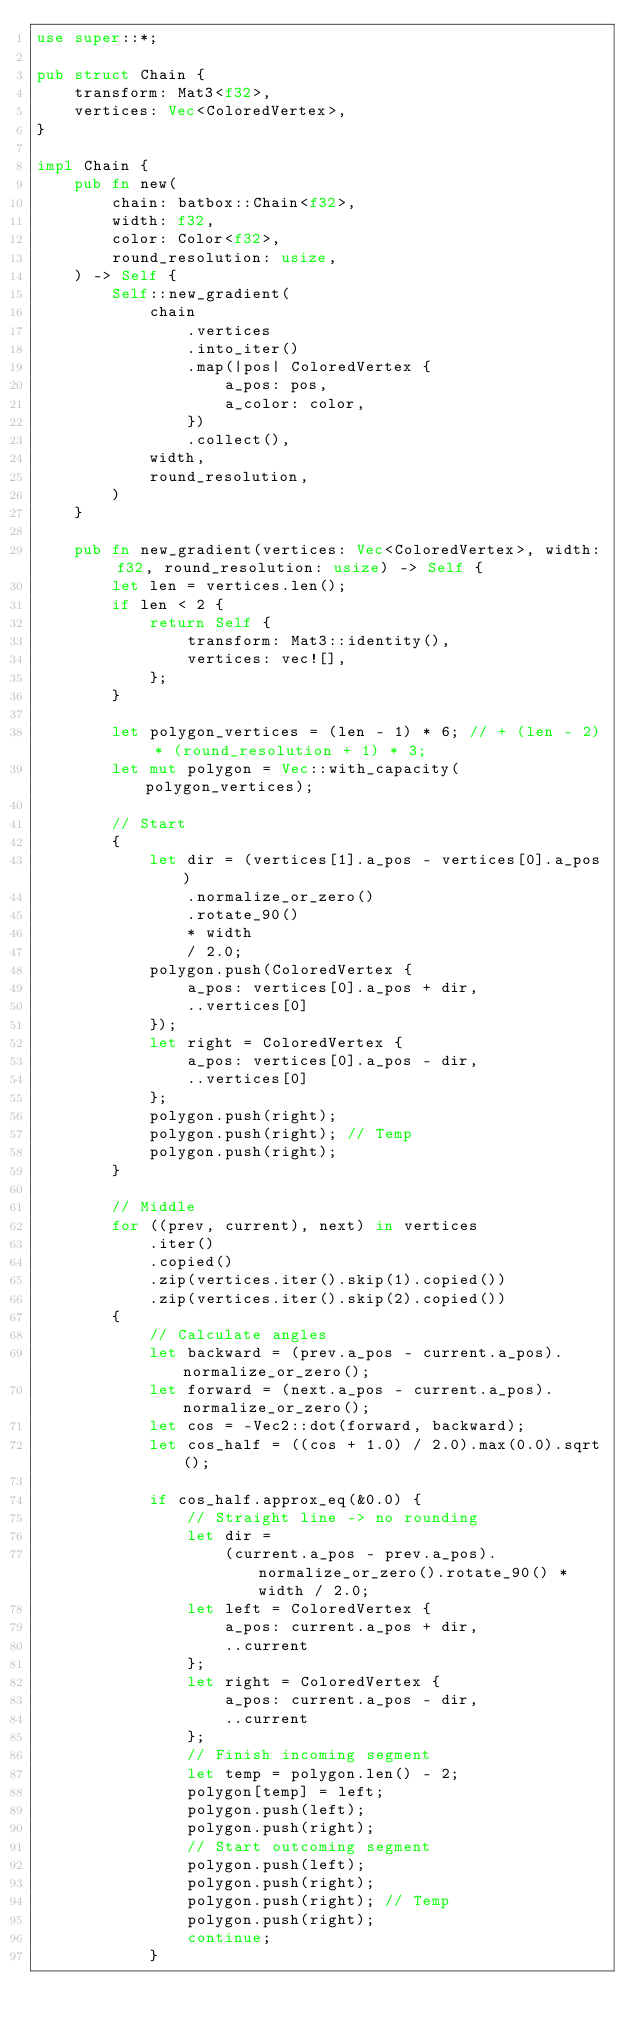<code> <loc_0><loc_0><loc_500><loc_500><_Rust_>use super::*;

pub struct Chain {
    transform: Mat3<f32>,
    vertices: Vec<ColoredVertex>,
}

impl Chain {
    pub fn new(
        chain: batbox::Chain<f32>,
        width: f32,
        color: Color<f32>,
        round_resolution: usize,
    ) -> Self {
        Self::new_gradient(
            chain
                .vertices
                .into_iter()
                .map(|pos| ColoredVertex {
                    a_pos: pos,
                    a_color: color,
                })
                .collect(),
            width,
            round_resolution,
        )
    }

    pub fn new_gradient(vertices: Vec<ColoredVertex>, width: f32, round_resolution: usize) -> Self {
        let len = vertices.len();
        if len < 2 {
            return Self {
                transform: Mat3::identity(),
                vertices: vec![],
            };
        }

        let polygon_vertices = (len - 1) * 6; // + (len - 2) * (round_resolution + 1) * 3;
        let mut polygon = Vec::with_capacity(polygon_vertices);

        // Start
        {
            let dir = (vertices[1].a_pos - vertices[0].a_pos)
                .normalize_or_zero()
                .rotate_90()
                * width
                / 2.0;
            polygon.push(ColoredVertex {
                a_pos: vertices[0].a_pos + dir,
                ..vertices[0]
            });
            let right = ColoredVertex {
                a_pos: vertices[0].a_pos - dir,
                ..vertices[0]
            };
            polygon.push(right);
            polygon.push(right); // Temp
            polygon.push(right);
        }

        // Middle
        for ((prev, current), next) in vertices
            .iter()
            .copied()
            .zip(vertices.iter().skip(1).copied())
            .zip(vertices.iter().skip(2).copied())
        {
            // Calculate angles
            let backward = (prev.a_pos - current.a_pos).normalize_or_zero();
            let forward = (next.a_pos - current.a_pos).normalize_or_zero();
            let cos = -Vec2::dot(forward, backward);
            let cos_half = ((cos + 1.0) / 2.0).max(0.0).sqrt();

            if cos_half.approx_eq(&0.0) {
                // Straight line -> no rounding
                let dir =
                    (current.a_pos - prev.a_pos).normalize_or_zero().rotate_90() * width / 2.0;
                let left = ColoredVertex {
                    a_pos: current.a_pos + dir,
                    ..current
                };
                let right = ColoredVertex {
                    a_pos: current.a_pos - dir,
                    ..current
                };
                // Finish incoming segment
                let temp = polygon.len() - 2;
                polygon[temp] = left;
                polygon.push(left);
                polygon.push(right);
                // Start outcoming segment
                polygon.push(left);
                polygon.push(right);
                polygon.push(right); // Temp
                polygon.push(right);
                continue;
            }
</code> 